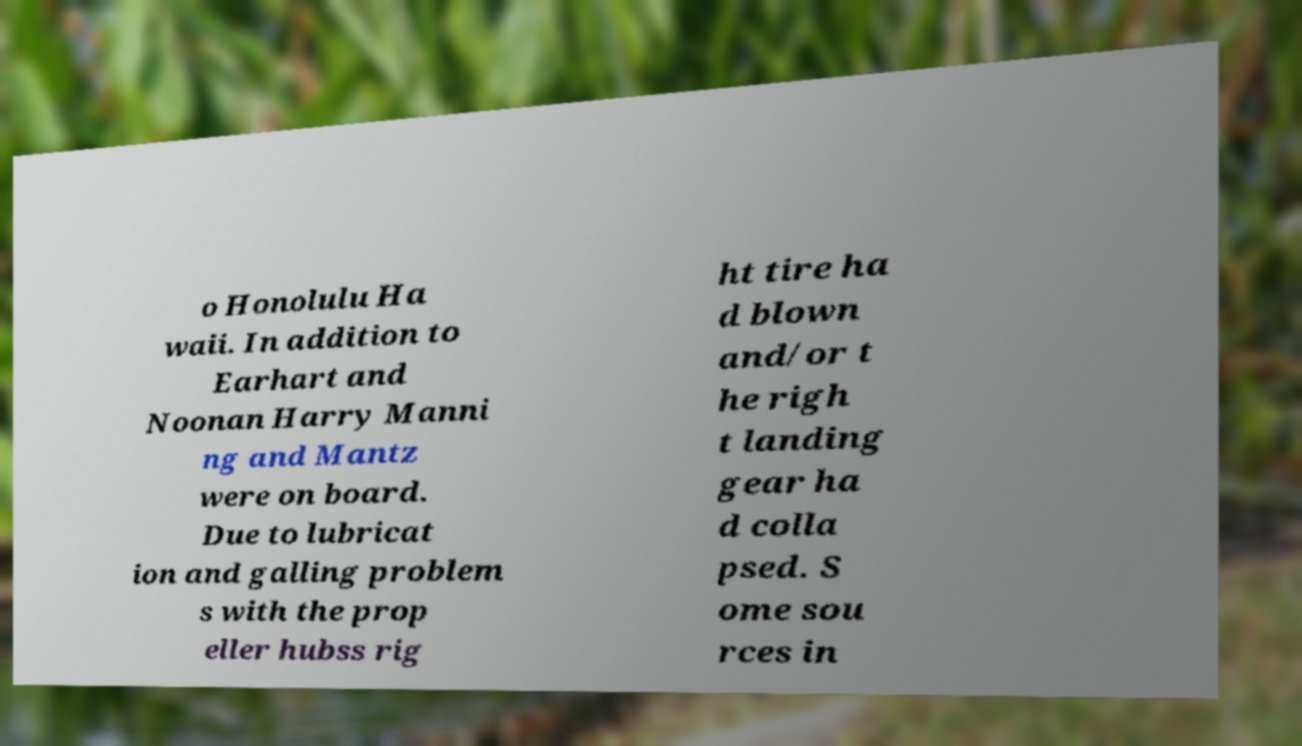Could you extract and type out the text from this image? o Honolulu Ha waii. In addition to Earhart and Noonan Harry Manni ng and Mantz were on board. Due to lubricat ion and galling problem s with the prop eller hubss rig ht tire ha d blown and/or t he righ t landing gear ha d colla psed. S ome sou rces in 